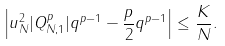<formula> <loc_0><loc_0><loc_500><loc_500>\left | u _ { N } ^ { 2 } | Q _ { N , 1 } ^ { p } | q ^ { p - 1 } - \frac { p } { 2 } q ^ { p - 1 } \right | \leq \frac { K } { N } .</formula> 